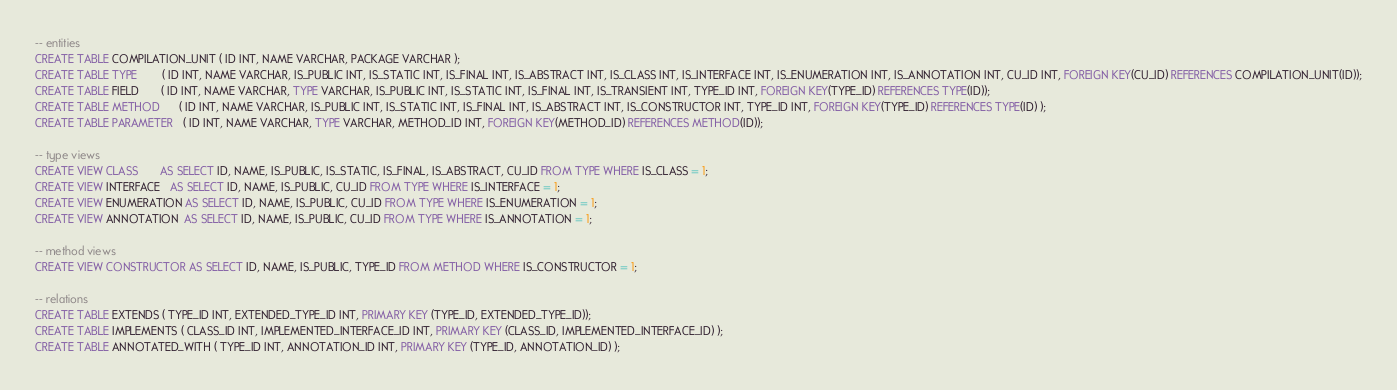<code> <loc_0><loc_0><loc_500><loc_500><_SQL_>-- entities
CREATE TABLE COMPILATION_UNIT ( ID INT, NAME VARCHAR, PACKAGE VARCHAR );
CREATE TABLE TYPE        ( ID INT, NAME VARCHAR, IS_PUBLIC INT, IS_STATIC INT, IS_FINAL INT, IS_ABSTRACT INT, IS_CLASS INT, IS_INTERFACE INT, IS_ENUMERATION INT, IS_ANNOTATION INT, CU_ID INT, FOREIGN KEY(CU_ID) REFERENCES COMPILATION_UNIT(ID));
CREATE TABLE FIELD       ( ID INT, NAME VARCHAR, TYPE VARCHAR, IS_PUBLIC INT, IS_STATIC INT, IS_FINAL INT, IS_TRANSIENT INT, TYPE_ID INT, FOREIGN KEY(TYPE_ID) REFERENCES TYPE(ID));
CREATE TABLE METHOD      ( ID INT, NAME VARCHAR, IS_PUBLIC INT, IS_STATIC INT, IS_FINAL INT, IS_ABSTRACT INT, IS_CONSTRUCTOR INT, TYPE_ID INT, FOREIGN KEY(TYPE_ID) REFERENCES TYPE(ID) );
CREATE TABLE PARAMETER   ( ID INT, NAME VARCHAR, TYPE VARCHAR, METHOD_ID INT, FOREIGN KEY(METHOD_ID) REFERENCES METHOD(ID));

-- type views
CREATE VIEW CLASS       AS SELECT ID, NAME, IS_PUBLIC, IS_STATIC, IS_FINAL, IS_ABSTRACT, CU_ID FROM TYPE WHERE IS_CLASS = 1;
CREATE VIEW INTERFACE   AS SELECT ID, NAME, IS_PUBLIC, CU_ID FROM TYPE WHERE IS_INTERFACE = 1;
CREATE VIEW ENUMERATION AS SELECT ID, NAME, IS_PUBLIC, CU_ID FROM TYPE WHERE IS_ENUMERATION = 1;
CREATE VIEW ANNOTATION  AS SELECT ID, NAME, IS_PUBLIC, CU_ID FROM TYPE WHERE IS_ANNOTATION = 1;

-- method views
CREATE VIEW CONSTRUCTOR AS SELECT ID, NAME, IS_PUBLIC, TYPE_ID FROM METHOD WHERE IS_CONSTRUCTOR = 1;

-- relations
CREATE TABLE EXTENDS ( TYPE_ID INT, EXTENDED_TYPE_ID INT, PRIMARY KEY (TYPE_ID, EXTENDED_TYPE_ID));
CREATE TABLE IMPLEMENTS ( CLASS_ID INT, IMPLEMENTED_INTERFACE_ID INT, PRIMARY KEY (CLASS_ID, IMPLEMENTED_INTERFACE_ID) );
CREATE TABLE ANNOTATED_WITH ( TYPE_ID INT, ANNOTATION_ID INT, PRIMARY KEY (TYPE_ID, ANNOTATION_ID) );</code> 